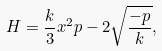<formula> <loc_0><loc_0><loc_500><loc_500>H = \frac { k } { 3 } x ^ { 2 } p - 2 \sqrt { \frac { - p } { k } } ,</formula> 